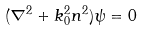Convert formula to latex. <formula><loc_0><loc_0><loc_500><loc_500>( \nabla ^ { 2 } + k _ { 0 } ^ { 2 } n ^ { 2 } ) \psi = 0</formula> 